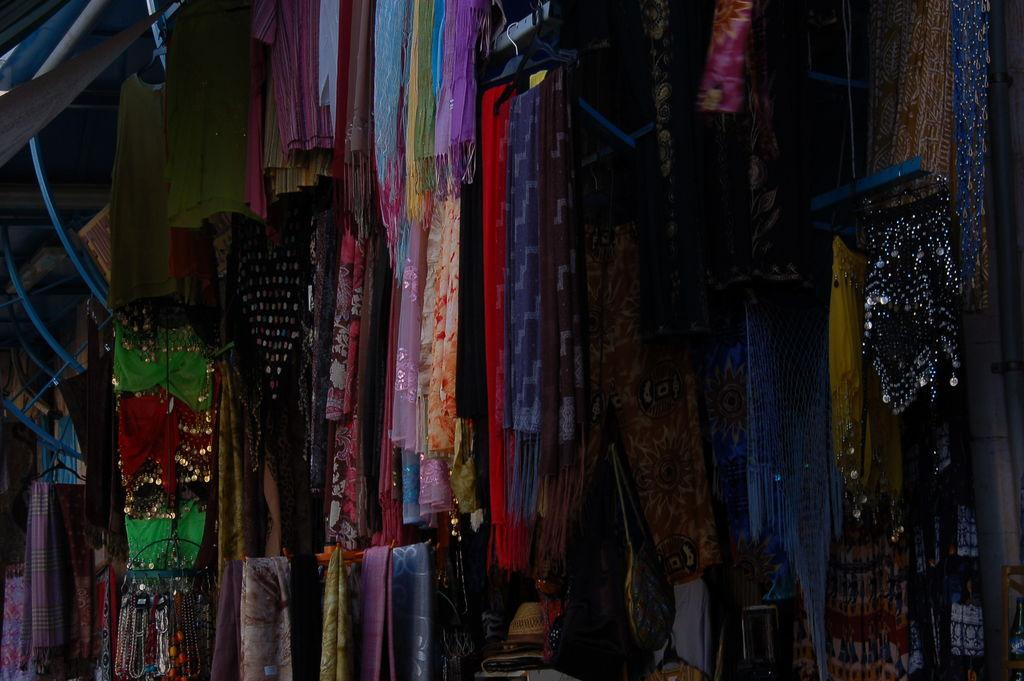What type of items can be seen in the image? There are clothes in the image. Are there any snails performing on a stage in the image? No, there are no snails or stage present in the image; it only features clothes. 